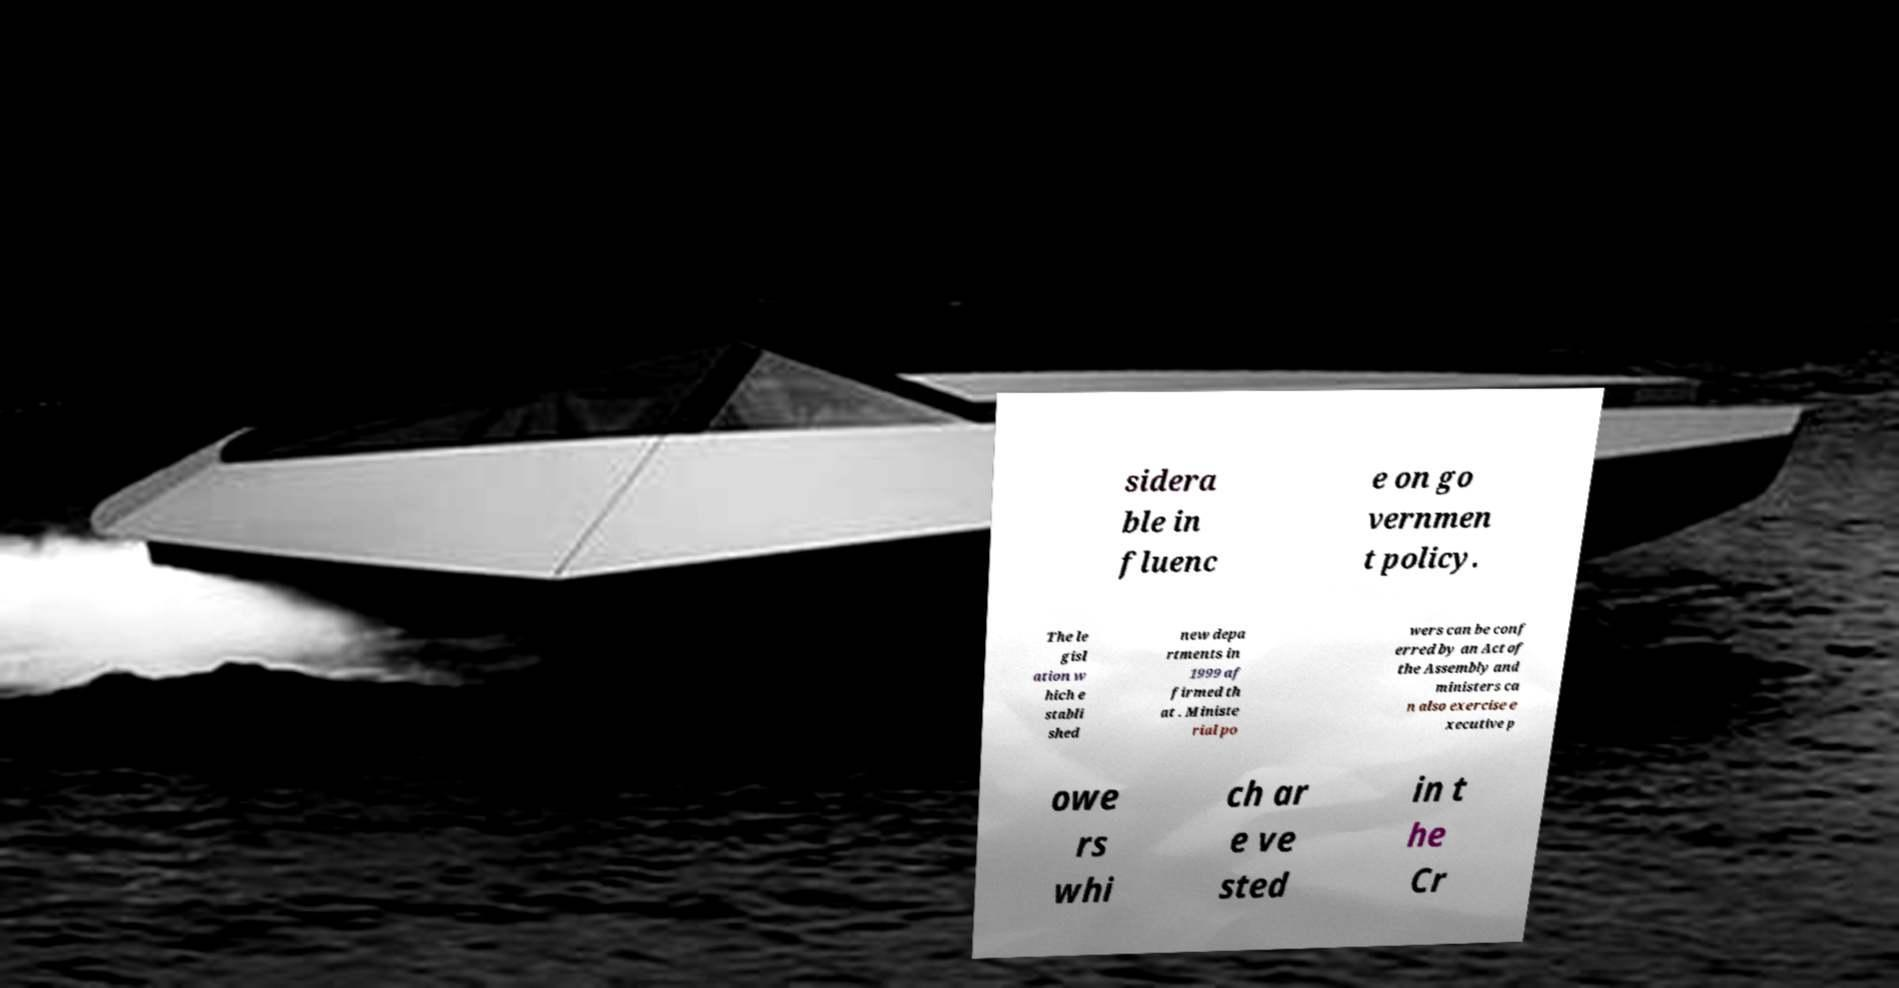I need the written content from this picture converted into text. Can you do that? sidera ble in fluenc e on go vernmen t policy. The le gisl ation w hich e stabli shed new depa rtments in 1999 af firmed th at . Ministe rial po wers can be conf erred by an Act of the Assembly and ministers ca n also exercise e xecutive p owe rs whi ch ar e ve sted in t he Cr 